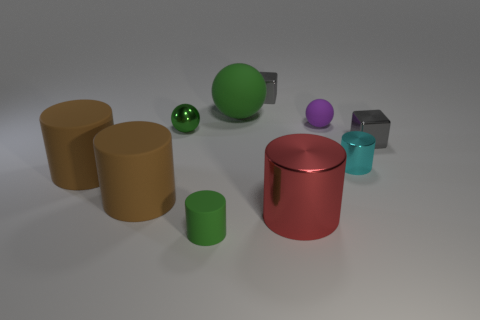Subtract 2 cylinders. How many cylinders are left? 3 Subtract all tiny green cylinders. How many cylinders are left? 4 Subtract all cyan cylinders. How many cylinders are left? 4 Subtract all red cylinders. Subtract all red balls. How many cylinders are left? 4 Subtract all spheres. How many objects are left? 7 Add 9 big red cylinders. How many big red cylinders exist? 10 Subtract 1 red cylinders. How many objects are left? 9 Subtract all tiny shiny cylinders. Subtract all brown objects. How many objects are left? 7 Add 1 big green balls. How many big green balls are left? 2 